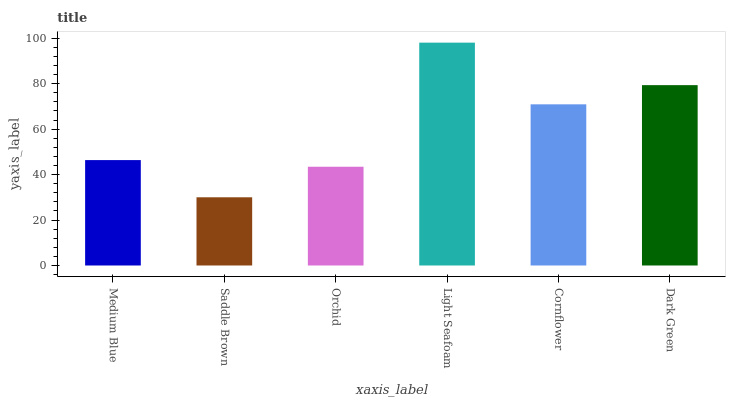Is Saddle Brown the minimum?
Answer yes or no. Yes. Is Light Seafoam the maximum?
Answer yes or no. Yes. Is Orchid the minimum?
Answer yes or no. No. Is Orchid the maximum?
Answer yes or no. No. Is Orchid greater than Saddle Brown?
Answer yes or no. Yes. Is Saddle Brown less than Orchid?
Answer yes or no. Yes. Is Saddle Brown greater than Orchid?
Answer yes or no. No. Is Orchid less than Saddle Brown?
Answer yes or no. No. Is Cornflower the high median?
Answer yes or no. Yes. Is Medium Blue the low median?
Answer yes or no. Yes. Is Saddle Brown the high median?
Answer yes or no. No. Is Saddle Brown the low median?
Answer yes or no. No. 